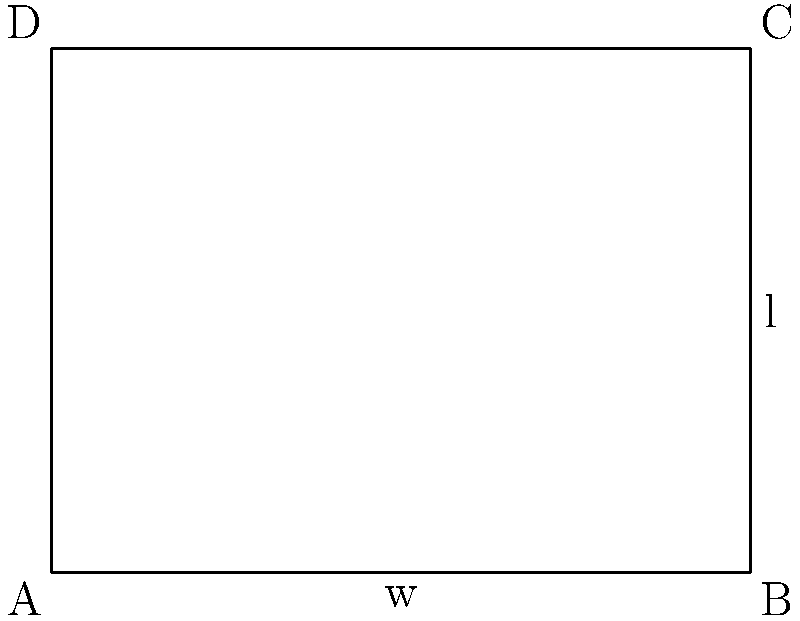You have 200 meters of fencing to enclose a rectangular land parcel. What dimensions (length and width) should you choose to maximize the area of the parcel, and what is the maximum area you can achieve? Let's approach this step-by-step:

1) Let the width of the rectangle be $w$ and the length be $l$.

2) Given that the perimeter is 200 meters, we can write:
   $2w + 2l = 200$
   $w + l = 100$

3) We want to maximize the area $A$, which is given by:
   $A = w \cdot l$

4) We can express $l$ in terms of $w$ using the perimeter equation:
   $l = 100 - w$

5) Now, we can express the area as a function of $w$:
   $A(w) = w(100-w) = 100w - w^2$

6) To find the maximum, we differentiate $A$ with respect to $w$ and set it to zero:
   $\frac{dA}{dw} = 100 - 2w = 0$
   $100 = 2w$
   $w = 50$

7) The second derivative is negative ($-2$), confirming this is a maximum.

8) If $w = 50$, then $l = 100 - 50 = 50$ as well.

9) The maximum area is therefore:
   $A_{max} = 50 \cdot 50 = 2500$ square meters

Therefore, to maximize the area, the parcel should be a square with sides of 50 meters each.
Answer: 50m x 50m square, 2500 sq m area 